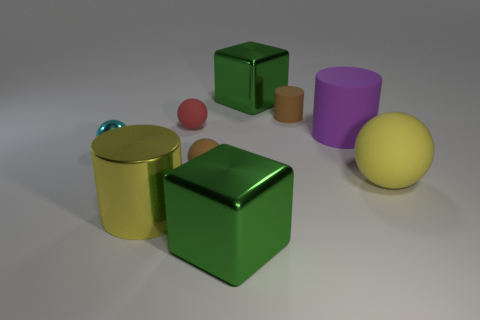Subtract all small spheres. How many spheres are left? 1 Subtract 1 cubes. How many cubes are left? 1 Add 1 things. How many objects exist? 10 Subtract all cyan balls. How many balls are left? 3 Subtract all cylinders. How many objects are left? 6 Add 8 green shiny objects. How many green shiny objects are left? 10 Add 7 red cubes. How many red cubes exist? 7 Subtract 1 brown cylinders. How many objects are left? 8 Subtract all yellow cubes. Subtract all purple balls. How many cubes are left? 2 Subtract all balls. Subtract all gray metal spheres. How many objects are left? 5 